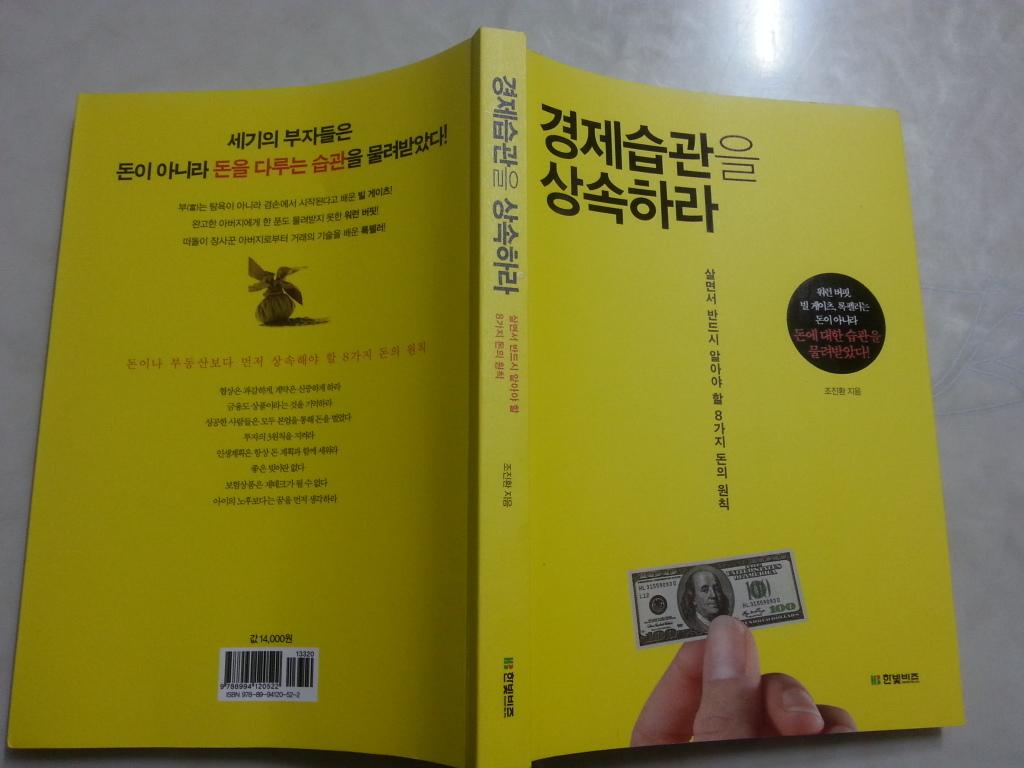How much is that bill on the cover worth in the us?
Your response must be concise. 100. What language is written on the book?
Your answer should be very brief. Unanswerable. 